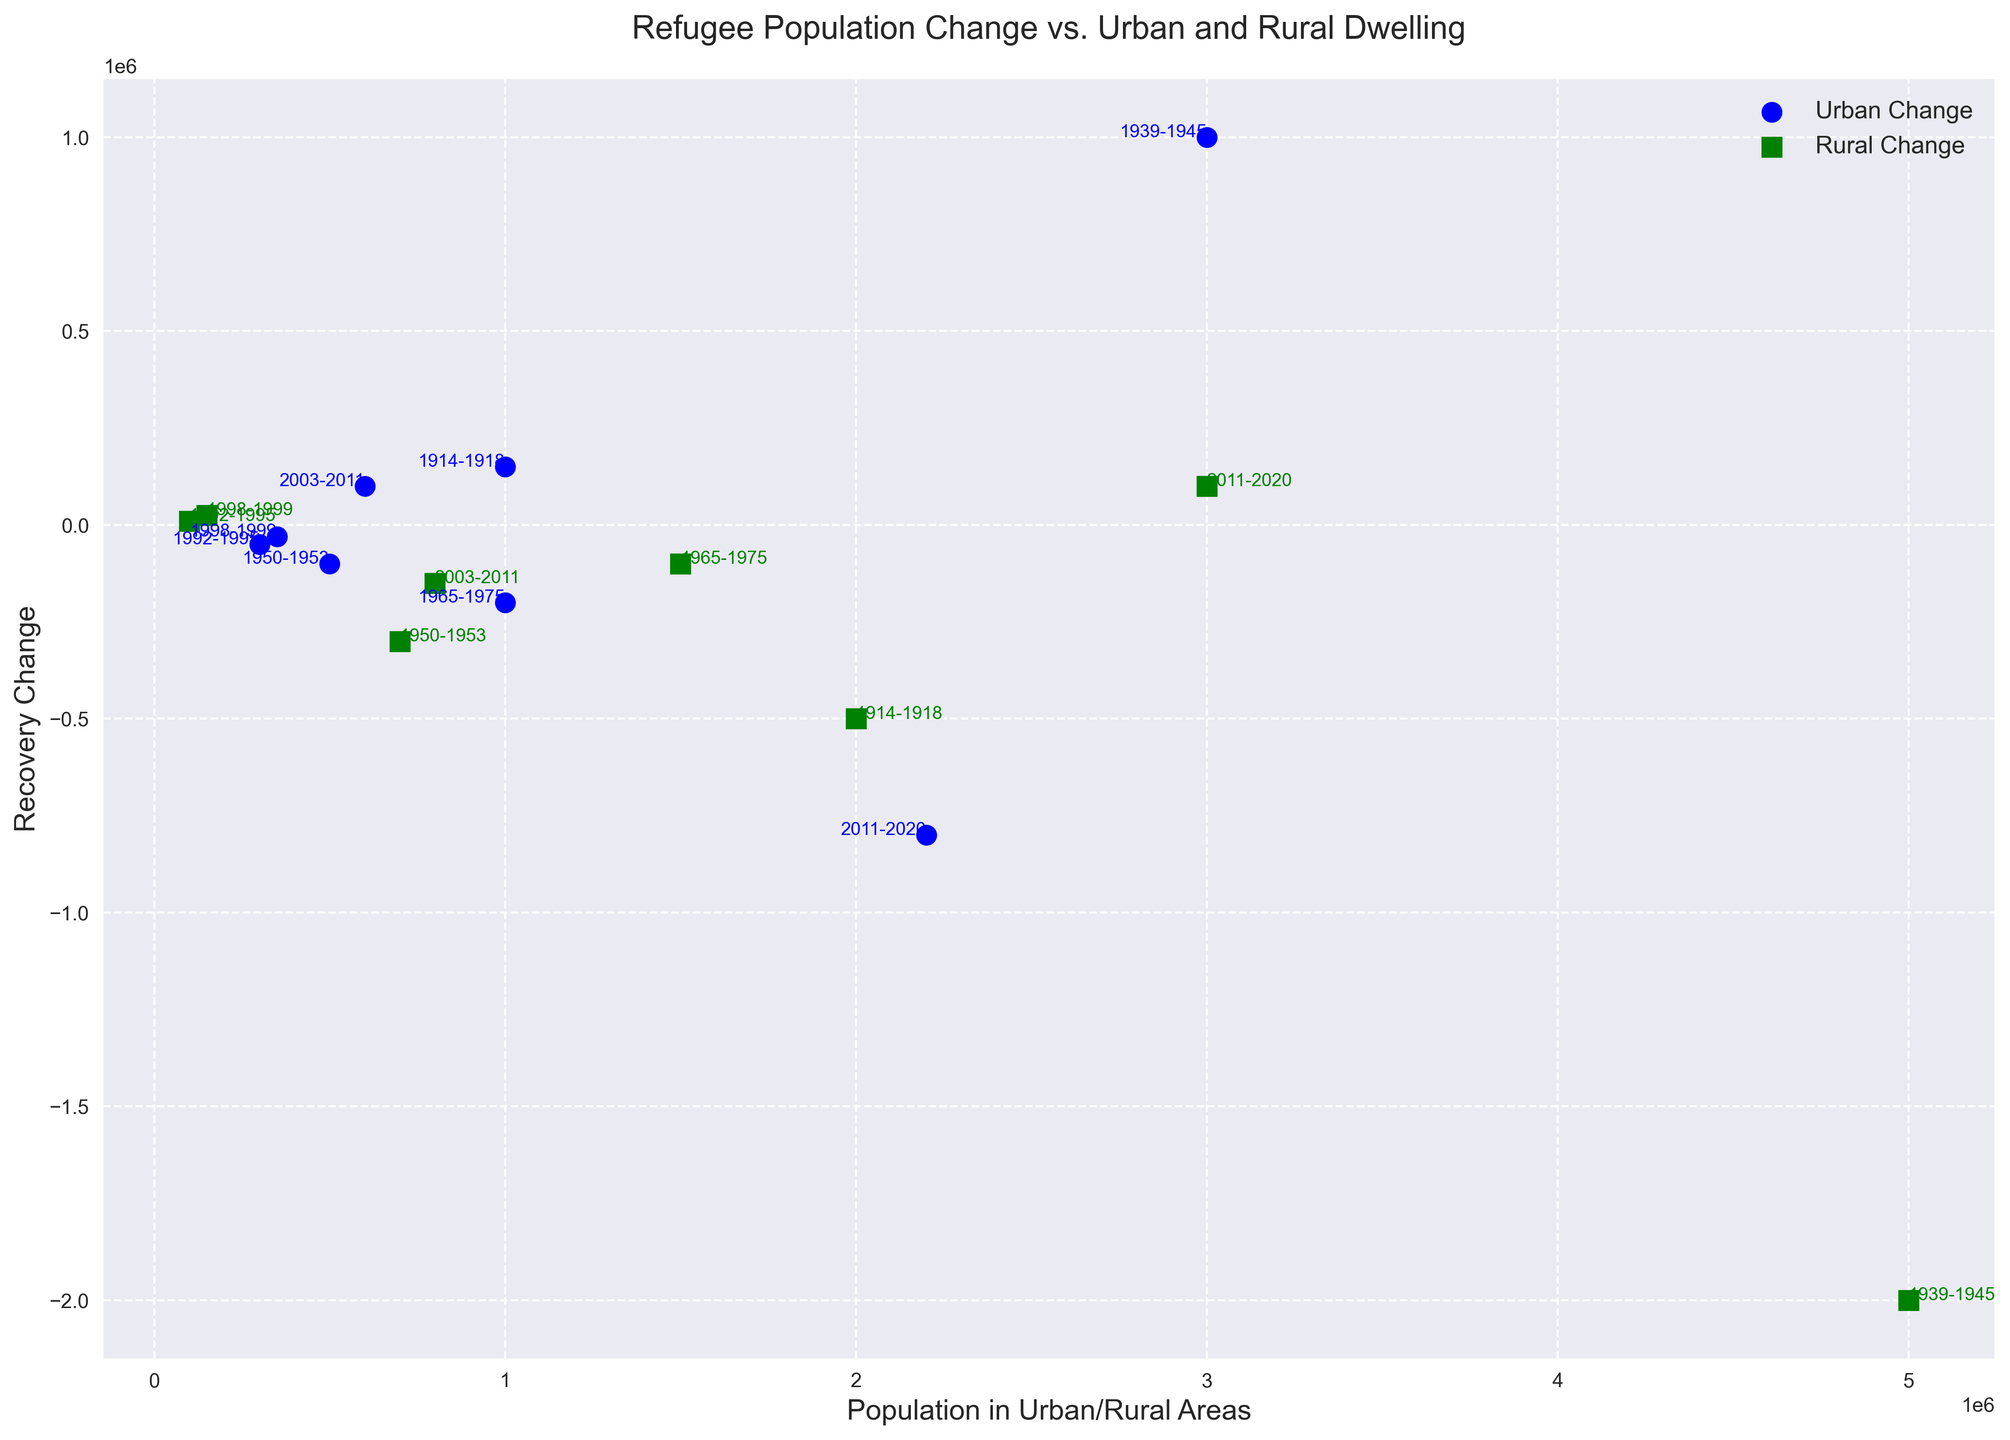Which period experienced the highest positive urban recovery change? Look at the values for Recovery_Urban_Change and identify the highest positive value. The period '1939-1945' during World War II has the highest value of 1000000.
Answer: 1939-1945 Which period saw the most significant negative rural recovery change? Look for the smallest (most negative) value in the Recovery_Rural_Change column. The period '1939-1945' during World War II has the most negative value of -2000000.
Answer: 1939-1945 Is there any period where urban recovery change and rural recovery change are both positive? Look for periods where both Recovery_Urban_Change and Recovery_Rural_Change have positive values. None of the periods have both values positive.
Answer: None Compare the rural dwelling populations during the Korean War and the Vietnam War. Which one had the higher rural population? Compare the Dwelling_Rural values for periods '1950-1953' (Korean War: 700000) and '1965-1975' (Vietnam War: 1500000). The Vietnam War period had the higher rural population.
Answer: Vietnam War What is the total urban population for all periods of conflict combined? Sum up all the Urban values: (1000000 + 3000000 + 500000 + 1000000 + 300000 + 350000 + 600000 + 2200000) = 8650000.
Answer: 8650000 Which two periods saw a negative urban recovery change, yet had a positive rural recovery change? Examine the values for Recovery_Urban_Change and Recovery_Rural_Change. The periods are '1992-1995' (Bosnian War: urban -50000, rural 10000) and '1998-1999' (Kosovo War: urban -30000, rural 25000).
Answer: 1992-1995, 1998-1999 How did the urban and rural recovery changes compare during the Syrian Civil War? The Recovery_Urban_Change for the Syrian Civil War is -800000, while the Recovery_Rural_Change is 100000. The urban change is negative while the rural change is slightly positive.
Answer: Urban change is negative, rural change is positive Which conflict period had the closest urban and rural dwelling populations? Calculate the absolute difference between Urban and Dwelling_Rural for each period and find the smallest difference. The period '2003-2011' (Iraq War) has Urban 600000 and Dwelling_Rural 800000, with the difference being 200000.
Answer: 2003-2011 Which war periods show a decline in both urban and rural recovery change? Look for periods where both Recovery_Urban_Change and Recovery_Rural_Change are negative. The periods are '1950-1953' (Korean War) with values of -100000 (urban) and -300000 (rural), and '1965-1975' (Vietnam War) with -200000 (urban) and -100000 (rural).
Answer: Korean War, Vietnam War 